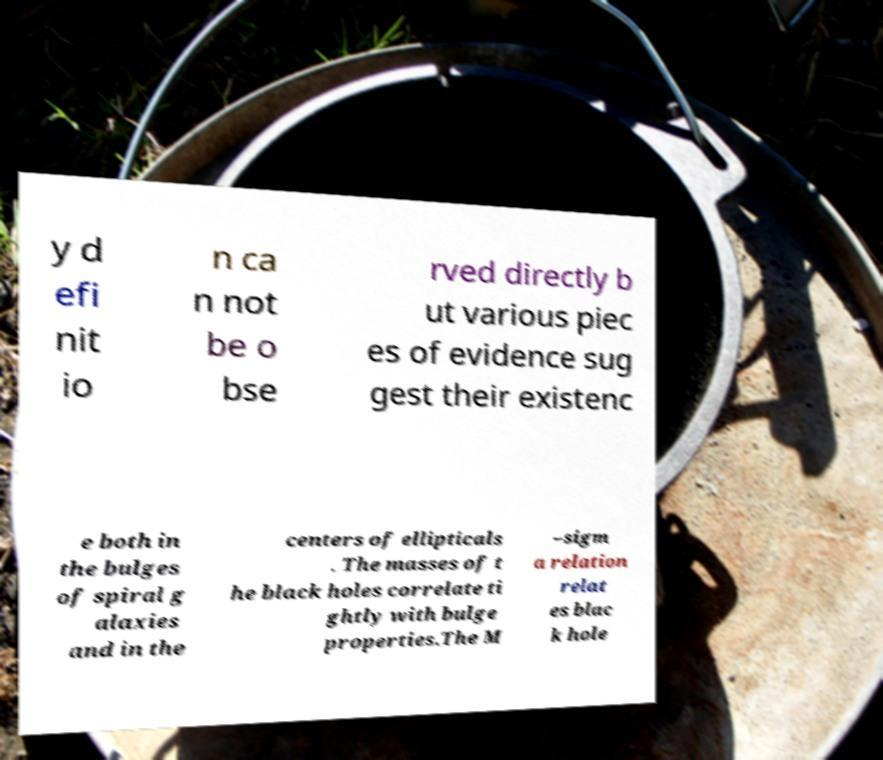Please read and relay the text visible in this image. What does it say? y d efi nit io n ca n not be o bse rved directly b ut various piec es of evidence sug gest their existenc e both in the bulges of spiral g alaxies and in the centers of ellipticals . The masses of t he black holes correlate ti ghtly with bulge properties.The M –sigm a relation relat es blac k hole 